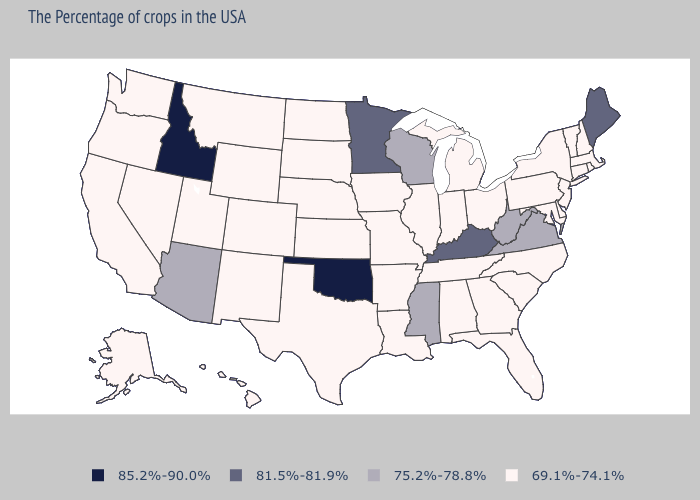Which states have the highest value in the USA?
Give a very brief answer. Oklahoma, Idaho. Does Oklahoma have the highest value in the USA?
Give a very brief answer. Yes. How many symbols are there in the legend?
Concise answer only. 4. Name the states that have a value in the range 69.1%-74.1%?
Concise answer only. Massachusetts, Rhode Island, New Hampshire, Vermont, Connecticut, New York, New Jersey, Delaware, Maryland, Pennsylvania, North Carolina, South Carolina, Ohio, Florida, Georgia, Michigan, Indiana, Alabama, Tennessee, Illinois, Louisiana, Missouri, Arkansas, Iowa, Kansas, Nebraska, Texas, South Dakota, North Dakota, Wyoming, Colorado, New Mexico, Utah, Montana, Nevada, California, Washington, Oregon, Alaska, Hawaii. Does Wisconsin have the lowest value in the MidWest?
Write a very short answer. No. Name the states that have a value in the range 85.2%-90.0%?
Keep it brief. Oklahoma, Idaho. Name the states that have a value in the range 85.2%-90.0%?
Answer briefly. Oklahoma, Idaho. Which states hav the highest value in the West?
Be succinct. Idaho. Name the states that have a value in the range 81.5%-81.9%?
Quick response, please. Maine, Kentucky, Minnesota. What is the value of Oklahoma?
Quick response, please. 85.2%-90.0%. Name the states that have a value in the range 75.2%-78.8%?
Quick response, please. Virginia, West Virginia, Wisconsin, Mississippi, Arizona. What is the lowest value in the USA?
Quick response, please. 69.1%-74.1%. Does Idaho have the highest value in the USA?
Be succinct. Yes. Does Kentucky have the same value as Wisconsin?
Keep it brief. No. Which states have the lowest value in the South?
Answer briefly. Delaware, Maryland, North Carolina, South Carolina, Florida, Georgia, Alabama, Tennessee, Louisiana, Arkansas, Texas. 